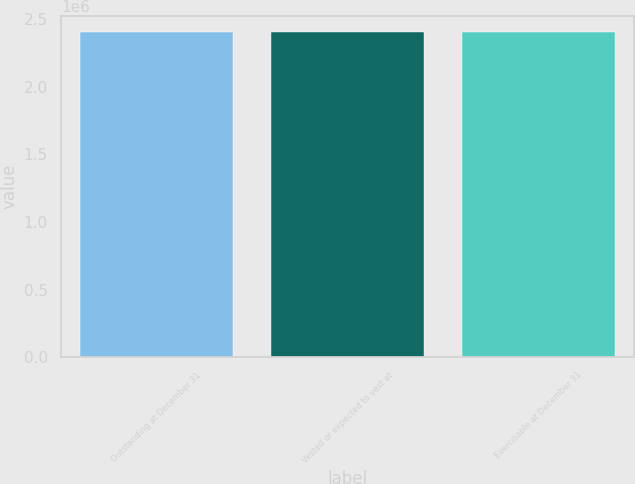Convert chart to OTSL. <chart><loc_0><loc_0><loc_500><loc_500><bar_chart><fcel>Outstanding at December 31<fcel>Vested or expected to vest at<fcel>Exercisable at December 31<nl><fcel>2.40492e+06<fcel>2.40493e+06<fcel>2.40493e+06<nl></chart> 